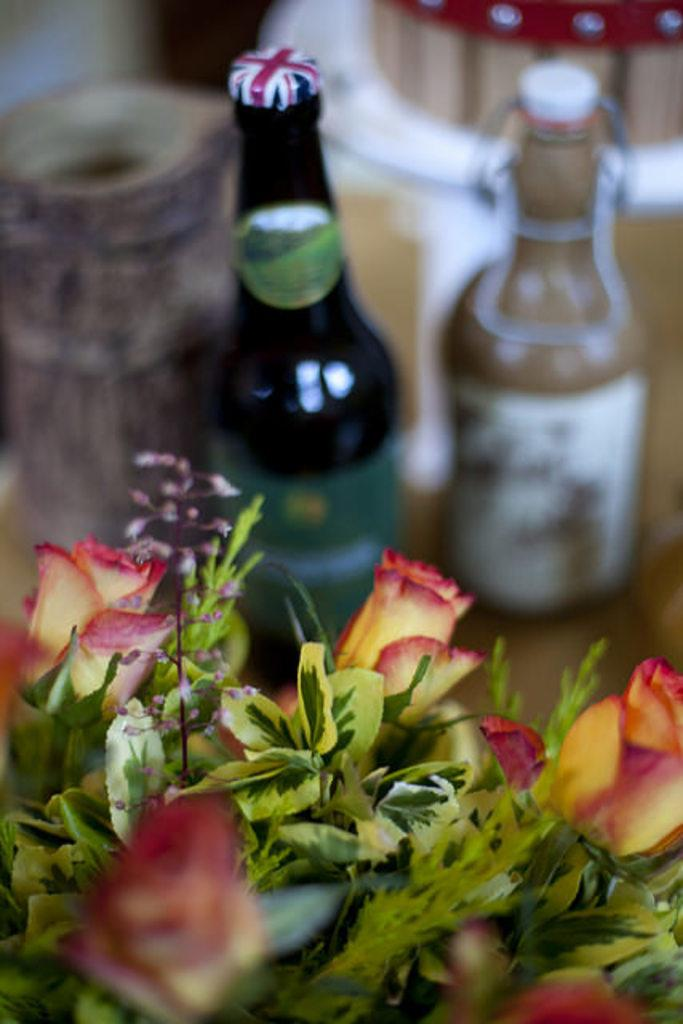What objects are located in the middle of the image? There are two bottles in the middle of the image. What can be seen at the bottom of the image? There is a flower vase at the bottom of the image. What type of insurance is being advertised on the lamp in the image? There is no lamp present in the image, so there is no insurance being advertised. 